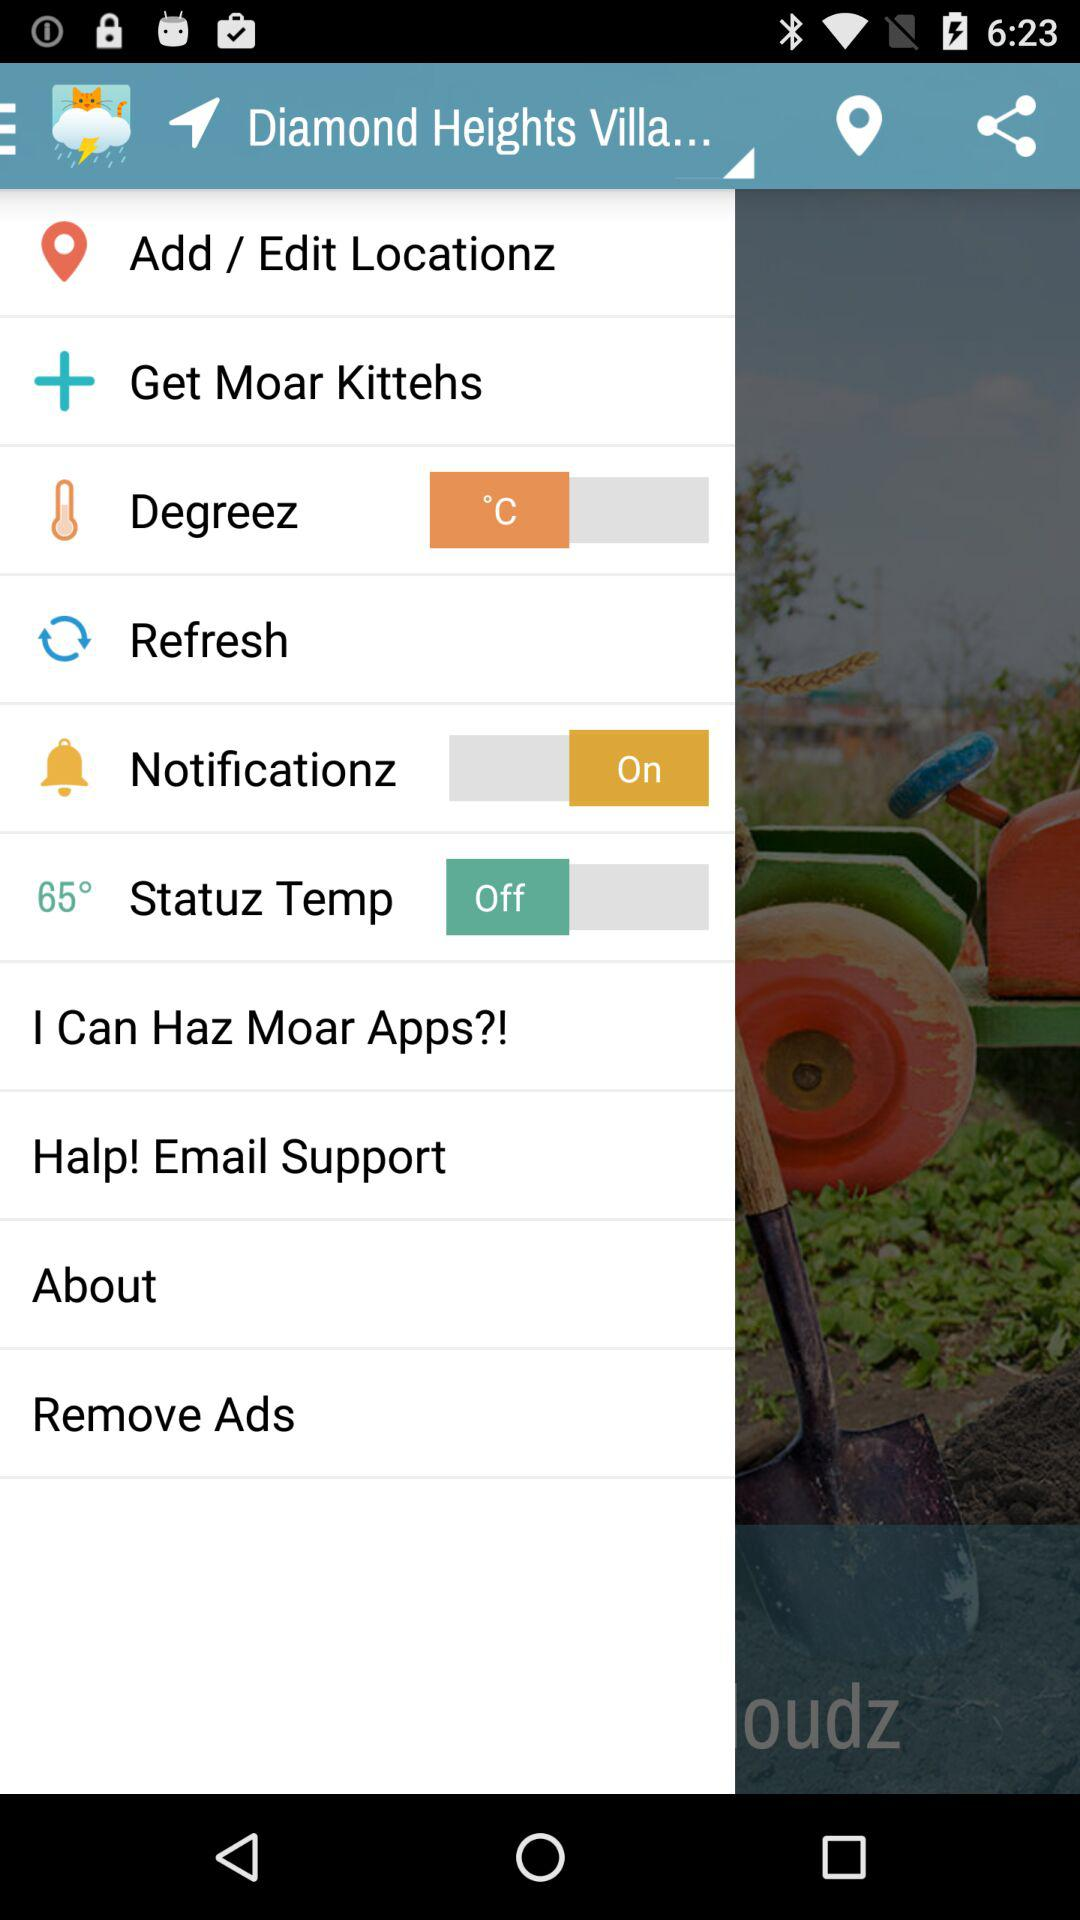What is the status of "Statuz Temp"? The status is off. 